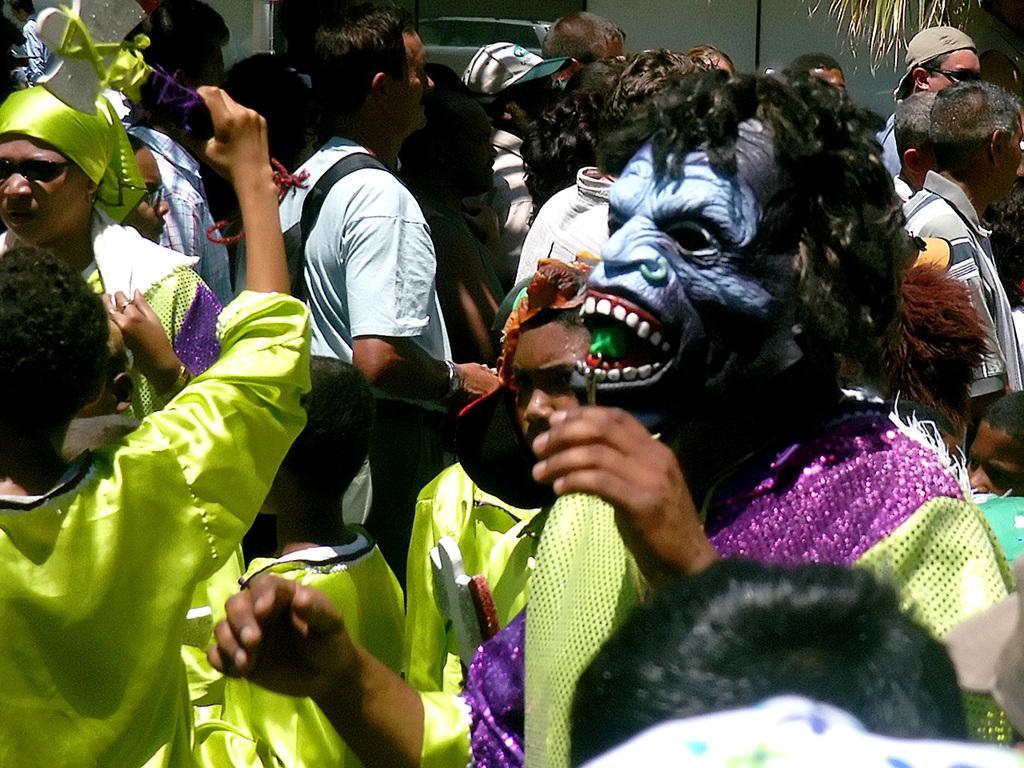Describe this image in one or two sentences. In this image I can see a crowd of people standing. Few people are wearing costumes. On the right side there is a person wearing a mask to the face. In the top right few leaves are visible. 